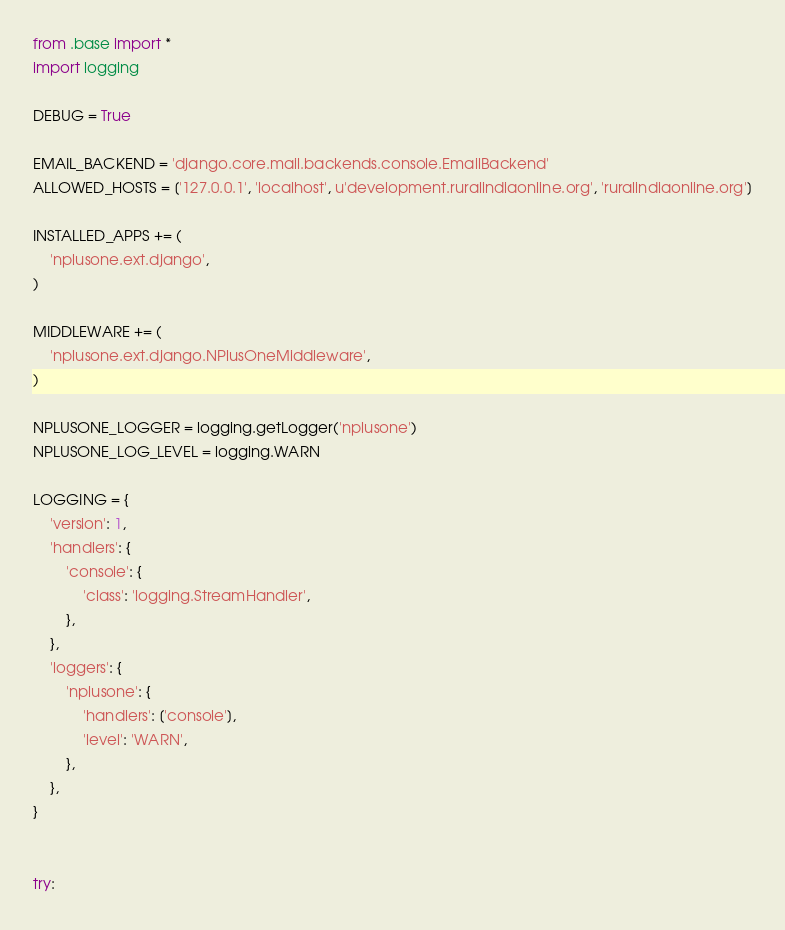<code> <loc_0><loc_0><loc_500><loc_500><_Python_>from .base import *
import logging

DEBUG = True

EMAIL_BACKEND = 'django.core.mail.backends.console.EmailBackend'
ALLOWED_HOSTS = ['127.0.0.1', 'localhost', u'development.ruralindiaonline.org', 'ruralindiaonline.org']

INSTALLED_APPS += (
    'nplusone.ext.django',
)

MIDDLEWARE += (
    'nplusone.ext.django.NPlusOneMiddleware',
)

NPLUSONE_LOGGER = logging.getLogger('nplusone')
NPLUSONE_LOG_LEVEL = logging.WARN

LOGGING = {
    'version': 1,
    'handlers': {
        'console': {
            'class': 'logging.StreamHandler',
        },
    },
    'loggers': {
        'nplusone': {
            'handlers': ['console'],
            'level': 'WARN',
        },
    },
}


try:</code> 